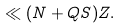<formula> <loc_0><loc_0><loc_500><loc_500>\ll ( N + Q S ) Z .</formula> 